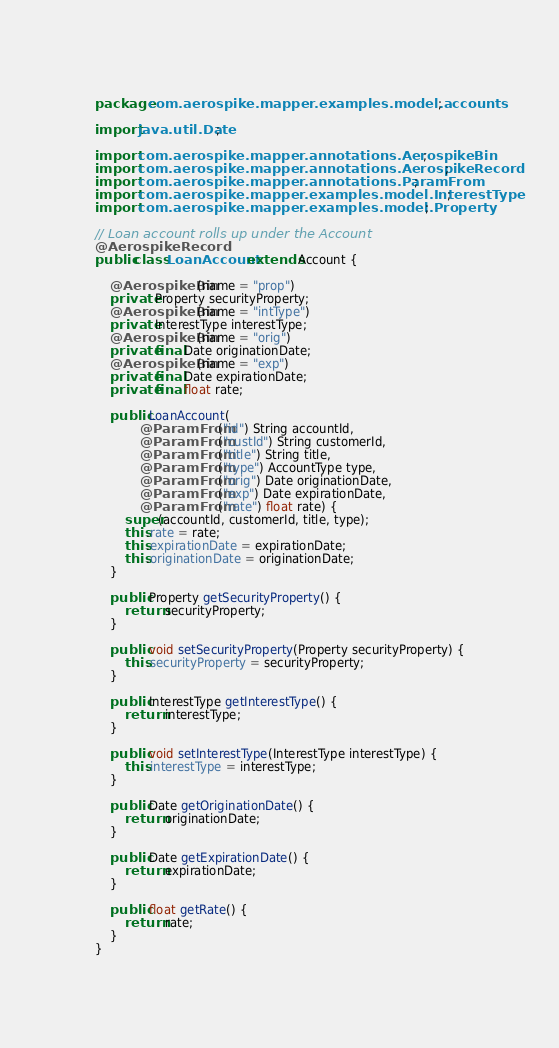Convert code to text. <code><loc_0><loc_0><loc_500><loc_500><_Java_>package com.aerospike.mapper.examples.model.accounts;

import java.util.Date;

import com.aerospike.mapper.annotations.AerospikeBin;
import com.aerospike.mapper.annotations.AerospikeRecord;
import com.aerospike.mapper.annotations.ParamFrom;
import com.aerospike.mapper.examples.model.InterestType;
import com.aerospike.mapper.examples.model.Property;

// Loan account rolls up under the Account
@AerospikeRecord
public class LoanAccount extends Account {

    @AerospikeBin(name = "prop")
    private Property securityProperty;
    @AerospikeBin(name = "intType")
    private InterestType interestType;
    @AerospikeBin(name = "orig")
    private final Date originationDate;
    @AerospikeBin(name = "exp")
    private final Date expirationDate;
    private final float rate;

    public LoanAccount(
            @ParamFrom("id") String accountId,
            @ParamFrom("custId") String customerId,
            @ParamFrom("title") String title,
            @ParamFrom("type") AccountType type,
            @ParamFrom("orig") Date originationDate,
            @ParamFrom("exp") Date expirationDate,
            @ParamFrom("rate") float rate) {
        super(accountId, customerId, title, type);
        this.rate = rate;
        this.expirationDate = expirationDate;
        this.originationDate = originationDate;
    }

    public Property getSecurityProperty() {
        return securityProperty;
    }

    public void setSecurityProperty(Property securityProperty) {
        this.securityProperty = securityProperty;
    }

    public InterestType getInterestType() {
        return interestType;
    }

    public void setInterestType(InterestType interestType) {
        this.interestType = interestType;
    }

    public Date getOriginationDate() {
        return originationDate;
    }

    public Date getExpirationDate() {
        return expirationDate;
    }

    public float getRate() {
        return rate;
    }
}
</code> 